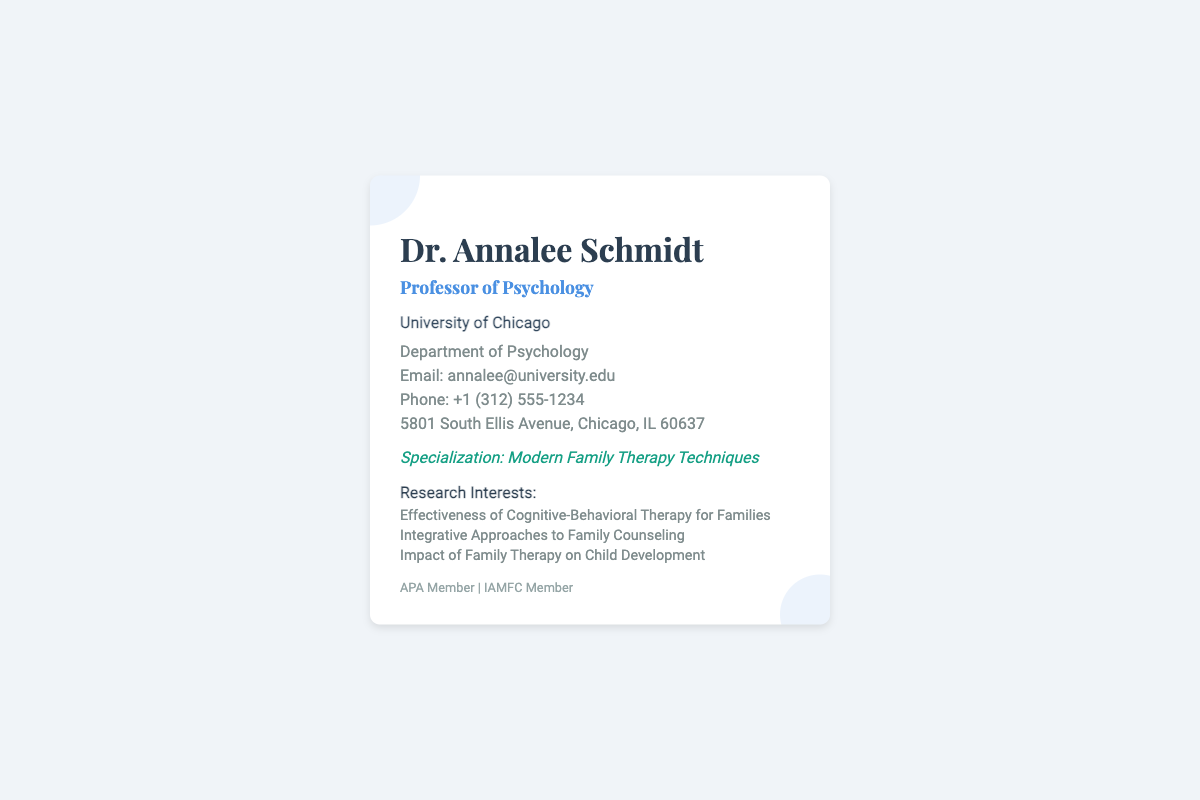What is Dr. Annalee Schmidt's title? Dr. Annalee Schmidt's title is given in the document as "Professor of Psychology".
Answer: Professor of Psychology Which university is Dr. Annalee Schmidt affiliated with? The document states that Dr. Annalee Schmidt is affiliated with the "University of Chicago".
Answer: University of Chicago What is Dr. Annalee Schmidt's email address? The email address is explicitly listed in the contact information section of the document.
Answer: annalee@university.edu What is the phone number provided on the card? The document specifies the phone number under the contact info section.
Answer: +1 (312) 555-1234 What is Dr. Annalee Schmidt's specialization? The document highlights her specialization as "Modern Family Therapy Techniques".
Answer: Modern Family Therapy Techniques How many research interests are listed? The document contains a list of research interests; counting them reveals there are three.
Answer: 3 What are two affiliations mentioned in the document? The affiliations listed in the document are "APA Member" and "IAMFC Member".
Answer: APA Member, IAMFC Member What department does Dr. Annalee Schmidt work in? The department is mentioned in the contact information provided in the document.
Answer: Department of Psychology What is the address provided on the business card? The full address is mentioned in the contact section, giving the location of the university.
Answer: 5801 South Ellis Avenue, Chicago, IL 60637 